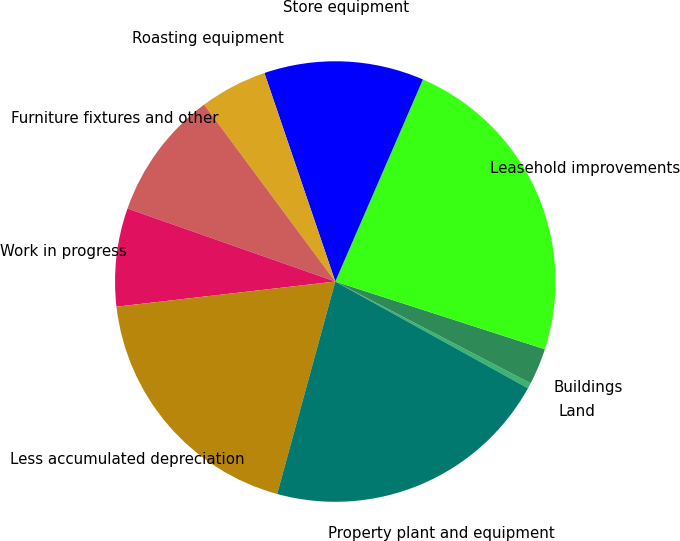Convert chart. <chart><loc_0><loc_0><loc_500><loc_500><pie_chart><fcel>Land<fcel>Buildings<fcel>Leasehold improvements<fcel>Store equipment<fcel>Roasting equipment<fcel>Furniture fixtures and other<fcel>Work in progress<fcel>Less accumulated depreciation<fcel>Property plant and equipment<nl><fcel>0.41%<fcel>2.67%<fcel>23.46%<fcel>11.73%<fcel>4.94%<fcel>9.47%<fcel>7.2%<fcel>18.93%<fcel>21.2%<nl></chart> 